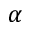Convert formula to latex. <formula><loc_0><loc_0><loc_500><loc_500>\alpha</formula> 